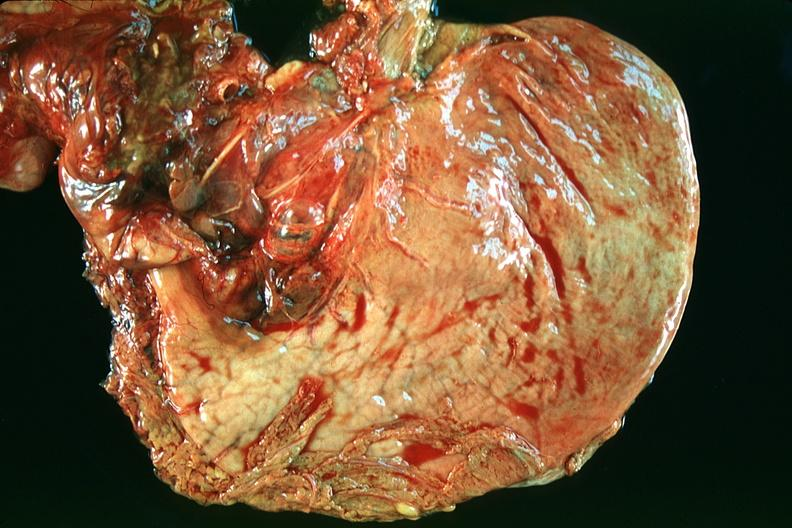does nodular tumor show normal stomach?
Answer the question using a single word or phrase. No 